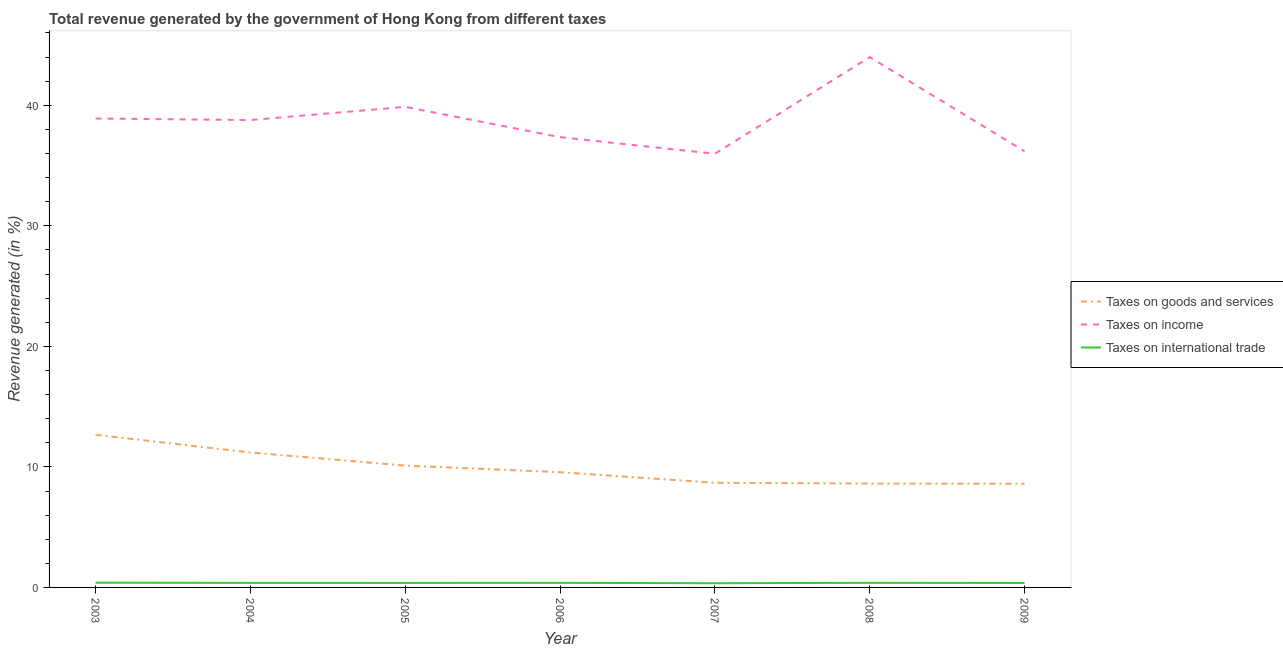How many different coloured lines are there?
Offer a terse response. 3. Does the line corresponding to percentage of revenue generated by tax on international trade intersect with the line corresponding to percentage of revenue generated by taxes on goods and services?
Your answer should be very brief. No. Is the number of lines equal to the number of legend labels?
Your answer should be very brief. Yes. What is the percentage of revenue generated by taxes on goods and services in 2003?
Provide a succinct answer. 12.66. Across all years, what is the maximum percentage of revenue generated by taxes on goods and services?
Provide a short and direct response. 12.66. Across all years, what is the minimum percentage of revenue generated by tax on international trade?
Your answer should be compact. 0.35. What is the total percentage of revenue generated by tax on international trade in the graph?
Keep it short and to the point. 2.62. What is the difference between the percentage of revenue generated by tax on international trade in 2003 and that in 2009?
Keep it short and to the point. 0.03. What is the difference between the percentage of revenue generated by taxes on goods and services in 2006 and the percentage of revenue generated by tax on international trade in 2005?
Offer a terse response. 9.18. What is the average percentage of revenue generated by taxes on income per year?
Your answer should be very brief. 38.72. In the year 2005, what is the difference between the percentage of revenue generated by taxes on income and percentage of revenue generated by taxes on goods and services?
Give a very brief answer. 29.76. What is the ratio of the percentage of revenue generated by taxes on income in 2003 to that in 2006?
Offer a very short reply. 1.04. Is the percentage of revenue generated by taxes on goods and services in 2008 less than that in 2009?
Provide a succinct answer. No. What is the difference between the highest and the second highest percentage of revenue generated by taxes on goods and services?
Your response must be concise. 1.47. What is the difference between the highest and the lowest percentage of revenue generated by taxes on goods and services?
Make the answer very short. 4.06. Is the sum of the percentage of revenue generated by taxes on goods and services in 2003 and 2004 greater than the maximum percentage of revenue generated by tax on international trade across all years?
Your answer should be compact. Yes. Is it the case that in every year, the sum of the percentage of revenue generated by taxes on goods and services and percentage of revenue generated by taxes on income is greater than the percentage of revenue generated by tax on international trade?
Your response must be concise. Yes. Does the percentage of revenue generated by taxes on income monotonically increase over the years?
Make the answer very short. No. How many lines are there?
Offer a very short reply. 3. Where does the legend appear in the graph?
Provide a succinct answer. Center right. How many legend labels are there?
Keep it short and to the point. 3. What is the title of the graph?
Give a very brief answer. Total revenue generated by the government of Hong Kong from different taxes. What is the label or title of the X-axis?
Your answer should be compact. Year. What is the label or title of the Y-axis?
Your answer should be very brief. Revenue generated (in %). What is the Revenue generated (in %) in Taxes on goods and services in 2003?
Keep it short and to the point. 12.66. What is the Revenue generated (in %) in Taxes on income in 2003?
Give a very brief answer. 38.9. What is the Revenue generated (in %) of Taxes on international trade in 2003?
Provide a short and direct response. 0.39. What is the Revenue generated (in %) in Taxes on goods and services in 2004?
Offer a very short reply. 11.2. What is the Revenue generated (in %) in Taxes on income in 2004?
Your answer should be very brief. 38.77. What is the Revenue generated (in %) in Taxes on international trade in 2004?
Provide a short and direct response. 0.38. What is the Revenue generated (in %) of Taxes on goods and services in 2005?
Offer a terse response. 10.11. What is the Revenue generated (in %) in Taxes on income in 2005?
Give a very brief answer. 39.87. What is the Revenue generated (in %) of Taxes on international trade in 2005?
Provide a succinct answer. 0.38. What is the Revenue generated (in %) in Taxes on goods and services in 2006?
Offer a terse response. 9.56. What is the Revenue generated (in %) in Taxes on income in 2006?
Provide a short and direct response. 37.36. What is the Revenue generated (in %) in Taxes on international trade in 2006?
Offer a very short reply. 0.38. What is the Revenue generated (in %) of Taxes on goods and services in 2007?
Provide a short and direct response. 8.68. What is the Revenue generated (in %) of Taxes on income in 2007?
Keep it short and to the point. 35.98. What is the Revenue generated (in %) in Taxes on international trade in 2007?
Your answer should be very brief. 0.35. What is the Revenue generated (in %) in Taxes on goods and services in 2008?
Offer a very short reply. 8.62. What is the Revenue generated (in %) of Taxes on income in 2008?
Your answer should be compact. 44. What is the Revenue generated (in %) of Taxes on international trade in 2008?
Keep it short and to the point. 0.38. What is the Revenue generated (in %) in Taxes on goods and services in 2009?
Offer a terse response. 8.6. What is the Revenue generated (in %) of Taxes on income in 2009?
Your answer should be compact. 36.18. What is the Revenue generated (in %) in Taxes on international trade in 2009?
Give a very brief answer. 0.37. Across all years, what is the maximum Revenue generated (in %) of Taxes on goods and services?
Offer a terse response. 12.66. Across all years, what is the maximum Revenue generated (in %) of Taxes on income?
Make the answer very short. 44. Across all years, what is the maximum Revenue generated (in %) in Taxes on international trade?
Provide a short and direct response. 0.39. Across all years, what is the minimum Revenue generated (in %) of Taxes on goods and services?
Ensure brevity in your answer.  8.6. Across all years, what is the minimum Revenue generated (in %) of Taxes on income?
Give a very brief answer. 35.98. Across all years, what is the minimum Revenue generated (in %) of Taxes on international trade?
Your answer should be compact. 0.35. What is the total Revenue generated (in %) of Taxes on goods and services in the graph?
Make the answer very short. 69.43. What is the total Revenue generated (in %) in Taxes on income in the graph?
Your answer should be compact. 271.06. What is the total Revenue generated (in %) in Taxes on international trade in the graph?
Keep it short and to the point. 2.62. What is the difference between the Revenue generated (in %) of Taxes on goods and services in 2003 and that in 2004?
Keep it short and to the point. 1.47. What is the difference between the Revenue generated (in %) in Taxes on income in 2003 and that in 2004?
Your answer should be compact. 0.13. What is the difference between the Revenue generated (in %) in Taxes on international trade in 2003 and that in 2004?
Make the answer very short. 0.02. What is the difference between the Revenue generated (in %) of Taxes on goods and services in 2003 and that in 2005?
Your response must be concise. 2.56. What is the difference between the Revenue generated (in %) of Taxes on income in 2003 and that in 2005?
Give a very brief answer. -0.97. What is the difference between the Revenue generated (in %) in Taxes on international trade in 2003 and that in 2005?
Keep it short and to the point. 0.02. What is the difference between the Revenue generated (in %) in Taxes on goods and services in 2003 and that in 2006?
Provide a short and direct response. 3.1. What is the difference between the Revenue generated (in %) of Taxes on income in 2003 and that in 2006?
Give a very brief answer. 1.55. What is the difference between the Revenue generated (in %) of Taxes on international trade in 2003 and that in 2006?
Give a very brief answer. 0.01. What is the difference between the Revenue generated (in %) of Taxes on goods and services in 2003 and that in 2007?
Your answer should be very brief. 3.98. What is the difference between the Revenue generated (in %) in Taxes on income in 2003 and that in 2007?
Keep it short and to the point. 2.93. What is the difference between the Revenue generated (in %) in Taxes on international trade in 2003 and that in 2007?
Your answer should be compact. 0.05. What is the difference between the Revenue generated (in %) in Taxes on goods and services in 2003 and that in 2008?
Your response must be concise. 4.05. What is the difference between the Revenue generated (in %) in Taxes on income in 2003 and that in 2008?
Keep it short and to the point. -5.09. What is the difference between the Revenue generated (in %) in Taxes on international trade in 2003 and that in 2008?
Provide a succinct answer. 0.01. What is the difference between the Revenue generated (in %) of Taxes on goods and services in 2003 and that in 2009?
Your answer should be very brief. 4.06. What is the difference between the Revenue generated (in %) of Taxes on income in 2003 and that in 2009?
Keep it short and to the point. 2.72. What is the difference between the Revenue generated (in %) in Taxes on international trade in 2003 and that in 2009?
Keep it short and to the point. 0.03. What is the difference between the Revenue generated (in %) in Taxes on goods and services in 2004 and that in 2005?
Ensure brevity in your answer.  1.09. What is the difference between the Revenue generated (in %) of Taxes on income in 2004 and that in 2005?
Your response must be concise. -1.1. What is the difference between the Revenue generated (in %) in Taxes on international trade in 2004 and that in 2005?
Your answer should be very brief. 0. What is the difference between the Revenue generated (in %) of Taxes on goods and services in 2004 and that in 2006?
Give a very brief answer. 1.64. What is the difference between the Revenue generated (in %) in Taxes on income in 2004 and that in 2006?
Give a very brief answer. 1.42. What is the difference between the Revenue generated (in %) of Taxes on international trade in 2004 and that in 2006?
Your response must be concise. -0. What is the difference between the Revenue generated (in %) of Taxes on goods and services in 2004 and that in 2007?
Your answer should be very brief. 2.51. What is the difference between the Revenue generated (in %) in Taxes on income in 2004 and that in 2007?
Your response must be concise. 2.8. What is the difference between the Revenue generated (in %) of Taxes on international trade in 2004 and that in 2007?
Provide a short and direct response. 0.03. What is the difference between the Revenue generated (in %) in Taxes on goods and services in 2004 and that in 2008?
Keep it short and to the point. 2.58. What is the difference between the Revenue generated (in %) of Taxes on income in 2004 and that in 2008?
Your answer should be compact. -5.22. What is the difference between the Revenue generated (in %) of Taxes on international trade in 2004 and that in 2008?
Make the answer very short. -0.01. What is the difference between the Revenue generated (in %) of Taxes on goods and services in 2004 and that in 2009?
Provide a succinct answer. 2.6. What is the difference between the Revenue generated (in %) of Taxes on income in 2004 and that in 2009?
Ensure brevity in your answer.  2.59. What is the difference between the Revenue generated (in %) of Taxes on international trade in 2004 and that in 2009?
Your answer should be very brief. 0.01. What is the difference between the Revenue generated (in %) in Taxes on goods and services in 2005 and that in 2006?
Offer a terse response. 0.55. What is the difference between the Revenue generated (in %) in Taxes on income in 2005 and that in 2006?
Provide a succinct answer. 2.52. What is the difference between the Revenue generated (in %) of Taxes on international trade in 2005 and that in 2006?
Give a very brief answer. -0. What is the difference between the Revenue generated (in %) in Taxes on goods and services in 2005 and that in 2007?
Provide a succinct answer. 1.42. What is the difference between the Revenue generated (in %) in Taxes on income in 2005 and that in 2007?
Offer a very short reply. 3.89. What is the difference between the Revenue generated (in %) of Taxes on international trade in 2005 and that in 2007?
Give a very brief answer. 0.03. What is the difference between the Revenue generated (in %) in Taxes on goods and services in 2005 and that in 2008?
Provide a succinct answer. 1.49. What is the difference between the Revenue generated (in %) of Taxes on income in 2005 and that in 2008?
Keep it short and to the point. -4.13. What is the difference between the Revenue generated (in %) in Taxes on international trade in 2005 and that in 2008?
Provide a succinct answer. -0.01. What is the difference between the Revenue generated (in %) of Taxes on goods and services in 2005 and that in 2009?
Keep it short and to the point. 1.51. What is the difference between the Revenue generated (in %) of Taxes on income in 2005 and that in 2009?
Make the answer very short. 3.69. What is the difference between the Revenue generated (in %) of Taxes on international trade in 2005 and that in 2009?
Ensure brevity in your answer.  0.01. What is the difference between the Revenue generated (in %) of Taxes on goods and services in 2006 and that in 2007?
Keep it short and to the point. 0.88. What is the difference between the Revenue generated (in %) in Taxes on income in 2006 and that in 2007?
Ensure brevity in your answer.  1.38. What is the difference between the Revenue generated (in %) of Taxes on international trade in 2006 and that in 2007?
Offer a terse response. 0.03. What is the difference between the Revenue generated (in %) of Taxes on goods and services in 2006 and that in 2008?
Your response must be concise. 0.94. What is the difference between the Revenue generated (in %) in Taxes on income in 2006 and that in 2008?
Your answer should be compact. -6.64. What is the difference between the Revenue generated (in %) in Taxes on international trade in 2006 and that in 2008?
Your answer should be very brief. -0. What is the difference between the Revenue generated (in %) in Taxes on goods and services in 2006 and that in 2009?
Give a very brief answer. 0.96. What is the difference between the Revenue generated (in %) of Taxes on income in 2006 and that in 2009?
Ensure brevity in your answer.  1.17. What is the difference between the Revenue generated (in %) in Taxes on international trade in 2006 and that in 2009?
Offer a terse response. 0.01. What is the difference between the Revenue generated (in %) of Taxes on goods and services in 2007 and that in 2008?
Provide a succinct answer. 0.07. What is the difference between the Revenue generated (in %) in Taxes on income in 2007 and that in 2008?
Your answer should be very brief. -8.02. What is the difference between the Revenue generated (in %) of Taxes on international trade in 2007 and that in 2008?
Give a very brief answer. -0.04. What is the difference between the Revenue generated (in %) in Taxes on goods and services in 2007 and that in 2009?
Keep it short and to the point. 0.08. What is the difference between the Revenue generated (in %) of Taxes on income in 2007 and that in 2009?
Offer a very short reply. -0.21. What is the difference between the Revenue generated (in %) of Taxes on international trade in 2007 and that in 2009?
Your response must be concise. -0.02. What is the difference between the Revenue generated (in %) of Taxes on goods and services in 2008 and that in 2009?
Offer a terse response. 0.02. What is the difference between the Revenue generated (in %) in Taxes on income in 2008 and that in 2009?
Your response must be concise. 7.81. What is the difference between the Revenue generated (in %) of Taxes on international trade in 2008 and that in 2009?
Your response must be concise. 0.01. What is the difference between the Revenue generated (in %) of Taxes on goods and services in 2003 and the Revenue generated (in %) of Taxes on income in 2004?
Ensure brevity in your answer.  -26.11. What is the difference between the Revenue generated (in %) of Taxes on goods and services in 2003 and the Revenue generated (in %) of Taxes on international trade in 2004?
Your answer should be compact. 12.29. What is the difference between the Revenue generated (in %) in Taxes on income in 2003 and the Revenue generated (in %) in Taxes on international trade in 2004?
Your response must be concise. 38.53. What is the difference between the Revenue generated (in %) in Taxes on goods and services in 2003 and the Revenue generated (in %) in Taxes on income in 2005?
Provide a succinct answer. -27.21. What is the difference between the Revenue generated (in %) in Taxes on goods and services in 2003 and the Revenue generated (in %) in Taxes on international trade in 2005?
Give a very brief answer. 12.29. What is the difference between the Revenue generated (in %) of Taxes on income in 2003 and the Revenue generated (in %) of Taxes on international trade in 2005?
Offer a very short reply. 38.53. What is the difference between the Revenue generated (in %) in Taxes on goods and services in 2003 and the Revenue generated (in %) in Taxes on income in 2006?
Offer a very short reply. -24.69. What is the difference between the Revenue generated (in %) in Taxes on goods and services in 2003 and the Revenue generated (in %) in Taxes on international trade in 2006?
Keep it short and to the point. 12.28. What is the difference between the Revenue generated (in %) in Taxes on income in 2003 and the Revenue generated (in %) in Taxes on international trade in 2006?
Offer a very short reply. 38.52. What is the difference between the Revenue generated (in %) in Taxes on goods and services in 2003 and the Revenue generated (in %) in Taxes on income in 2007?
Offer a very short reply. -23.31. What is the difference between the Revenue generated (in %) in Taxes on goods and services in 2003 and the Revenue generated (in %) in Taxes on international trade in 2007?
Keep it short and to the point. 12.32. What is the difference between the Revenue generated (in %) in Taxes on income in 2003 and the Revenue generated (in %) in Taxes on international trade in 2007?
Ensure brevity in your answer.  38.56. What is the difference between the Revenue generated (in %) in Taxes on goods and services in 2003 and the Revenue generated (in %) in Taxes on income in 2008?
Your answer should be very brief. -31.33. What is the difference between the Revenue generated (in %) of Taxes on goods and services in 2003 and the Revenue generated (in %) of Taxes on international trade in 2008?
Offer a terse response. 12.28. What is the difference between the Revenue generated (in %) of Taxes on income in 2003 and the Revenue generated (in %) of Taxes on international trade in 2008?
Your answer should be compact. 38.52. What is the difference between the Revenue generated (in %) in Taxes on goods and services in 2003 and the Revenue generated (in %) in Taxes on income in 2009?
Make the answer very short. -23.52. What is the difference between the Revenue generated (in %) in Taxes on goods and services in 2003 and the Revenue generated (in %) in Taxes on international trade in 2009?
Keep it short and to the point. 12.3. What is the difference between the Revenue generated (in %) of Taxes on income in 2003 and the Revenue generated (in %) of Taxes on international trade in 2009?
Offer a very short reply. 38.54. What is the difference between the Revenue generated (in %) of Taxes on goods and services in 2004 and the Revenue generated (in %) of Taxes on income in 2005?
Offer a very short reply. -28.67. What is the difference between the Revenue generated (in %) of Taxes on goods and services in 2004 and the Revenue generated (in %) of Taxes on international trade in 2005?
Ensure brevity in your answer.  10.82. What is the difference between the Revenue generated (in %) in Taxes on income in 2004 and the Revenue generated (in %) in Taxes on international trade in 2005?
Offer a very short reply. 38.4. What is the difference between the Revenue generated (in %) in Taxes on goods and services in 2004 and the Revenue generated (in %) in Taxes on income in 2006?
Keep it short and to the point. -26.16. What is the difference between the Revenue generated (in %) of Taxes on goods and services in 2004 and the Revenue generated (in %) of Taxes on international trade in 2006?
Provide a succinct answer. 10.82. What is the difference between the Revenue generated (in %) in Taxes on income in 2004 and the Revenue generated (in %) in Taxes on international trade in 2006?
Your answer should be compact. 38.39. What is the difference between the Revenue generated (in %) in Taxes on goods and services in 2004 and the Revenue generated (in %) in Taxes on income in 2007?
Keep it short and to the point. -24.78. What is the difference between the Revenue generated (in %) of Taxes on goods and services in 2004 and the Revenue generated (in %) of Taxes on international trade in 2007?
Your answer should be compact. 10.85. What is the difference between the Revenue generated (in %) of Taxes on income in 2004 and the Revenue generated (in %) of Taxes on international trade in 2007?
Ensure brevity in your answer.  38.43. What is the difference between the Revenue generated (in %) of Taxes on goods and services in 2004 and the Revenue generated (in %) of Taxes on income in 2008?
Give a very brief answer. -32.8. What is the difference between the Revenue generated (in %) in Taxes on goods and services in 2004 and the Revenue generated (in %) in Taxes on international trade in 2008?
Give a very brief answer. 10.81. What is the difference between the Revenue generated (in %) of Taxes on income in 2004 and the Revenue generated (in %) of Taxes on international trade in 2008?
Your answer should be compact. 38.39. What is the difference between the Revenue generated (in %) in Taxes on goods and services in 2004 and the Revenue generated (in %) in Taxes on income in 2009?
Offer a terse response. -24.99. What is the difference between the Revenue generated (in %) of Taxes on goods and services in 2004 and the Revenue generated (in %) of Taxes on international trade in 2009?
Your response must be concise. 10.83. What is the difference between the Revenue generated (in %) in Taxes on income in 2004 and the Revenue generated (in %) in Taxes on international trade in 2009?
Provide a succinct answer. 38.41. What is the difference between the Revenue generated (in %) of Taxes on goods and services in 2005 and the Revenue generated (in %) of Taxes on income in 2006?
Offer a very short reply. -27.25. What is the difference between the Revenue generated (in %) of Taxes on goods and services in 2005 and the Revenue generated (in %) of Taxes on international trade in 2006?
Keep it short and to the point. 9.73. What is the difference between the Revenue generated (in %) of Taxes on income in 2005 and the Revenue generated (in %) of Taxes on international trade in 2006?
Make the answer very short. 39.49. What is the difference between the Revenue generated (in %) of Taxes on goods and services in 2005 and the Revenue generated (in %) of Taxes on income in 2007?
Provide a short and direct response. -25.87. What is the difference between the Revenue generated (in %) in Taxes on goods and services in 2005 and the Revenue generated (in %) in Taxes on international trade in 2007?
Ensure brevity in your answer.  9.76. What is the difference between the Revenue generated (in %) of Taxes on income in 2005 and the Revenue generated (in %) of Taxes on international trade in 2007?
Make the answer very short. 39.52. What is the difference between the Revenue generated (in %) of Taxes on goods and services in 2005 and the Revenue generated (in %) of Taxes on income in 2008?
Provide a succinct answer. -33.89. What is the difference between the Revenue generated (in %) of Taxes on goods and services in 2005 and the Revenue generated (in %) of Taxes on international trade in 2008?
Provide a short and direct response. 9.72. What is the difference between the Revenue generated (in %) of Taxes on income in 2005 and the Revenue generated (in %) of Taxes on international trade in 2008?
Your answer should be very brief. 39.49. What is the difference between the Revenue generated (in %) of Taxes on goods and services in 2005 and the Revenue generated (in %) of Taxes on income in 2009?
Offer a very short reply. -26.08. What is the difference between the Revenue generated (in %) in Taxes on goods and services in 2005 and the Revenue generated (in %) in Taxes on international trade in 2009?
Keep it short and to the point. 9.74. What is the difference between the Revenue generated (in %) of Taxes on income in 2005 and the Revenue generated (in %) of Taxes on international trade in 2009?
Ensure brevity in your answer.  39.5. What is the difference between the Revenue generated (in %) of Taxes on goods and services in 2006 and the Revenue generated (in %) of Taxes on income in 2007?
Offer a very short reply. -26.42. What is the difference between the Revenue generated (in %) in Taxes on goods and services in 2006 and the Revenue generated (in %) in Taxes on international trade in 2007?
Provide a succinct answer. 9.21. What is the difference between the Revenue generated (in %) in Taxes on income in 2006 and the Revenue generated (in %) in Taxes on international trade in 2007?
Keep it short and to the point. 37.01. What is the difference between the Revenue generated (in %) of Taxes on goods and services in 2006 and the Revenue generated (in %) of Taxes on income in 2008?
Provide a succinct answer. -34.44. What is the difference between the Revenue generated (in %) in Taxes on goods and services in 2006 and the Revenue generated (in %) in Taxes on international trade in 2008?
Provide a succinct answer. 9.18. What is the difference between the Revenue generated (in %) in Taxes on income in 2006 and the Revenue generated (in %) in Taxes on international trade in 2008?
Give a very brief answer. 36.97. What is the difference between the Revenue generated (in %) of Taxes on goods and services in 2006 and the Revenue generated (in %) of Taxes on income in 2009?
Offer a very short reply. -26.62. What is the difference between the Revenue generated (in %) in Taxes on goods and services in 2006 and the Revenue generated (in %) in Taxes on international trade in 2009?
Keep it short and to the point. 9.19. What is the difference between the Revenue generated (in %) of Taxes on income in 2006 and the Revenue generated (in %) of Taxes on international trade in 2009?
Keep it short and to the point. 36.99. What is the difference between the Revenue generated (in %) in Taxes on goods and services in 2007 and the Revenue generated (in %) in Taxes on income in 2008?
Keep it short and to the point. -35.31. What is the difference between the Revenue generated (in %) in Taxes on goods and services in 2007 and the Revenue generated (in %) in Taxes on international trade in 2008?
Provide a short and direct response. 8.3. What is the difference between the Revenue generated (in %) of Taxes on income in 2007 and the Revenue generated (in %) of Taxes on international trade in 2008?
Make the answer very short. 35.6. What is the difference between the Revenue generated (in %) of Taxes on goods and services in 2007 and the Revenue generated (in %) of Taxes on income in 2009?
Your response must be concise. -27.5. What is the difference between the Revenue generated (in %) in Taxes on goods and services in 2007 and the Revenue generated (in %) in Taxes on international trade in 2009?
Keep it short and to the point. 8.31. What is the difference between the Revenue generated (in %) of Taxes on income in 2007 and the Revenue generated (in %) of Taxes on international trade in 2009?
Offer a terse response. 35.61. What is the difference between the Revenue generated (in %) in Taxes on goods and services in 2008 and the Revenue generated (in %) in Taxes on income in 2009?
Ensure brevity in your answer.  -27.57. What is the difference between the Revenue generated (in %) of Taxes on goods and services in 2008 and the Revenue generated (in %) of Taxes on international trade in 2009?
Make the answer very short. 8.25. What is the difference between the Revenue generated (in %) in Taxes on income in 2008 and the Revenue generated (in %) in Taxes on international trade in 2009?
Your answer should be compact. 43.63. What is the average Revenue generated (in %) in Taxes on goods and services per year?
Your answer should be very brief. 9.92. What is the average Revenue generated (in %) in Taxes on income per year?
Give a very brief answer. 38.72. What is the average Revenue generated (in %) of Taxes on international trade per year?
Ensure brevity in your answer.  0.38. In the year 2003, what is the difference between the Revenue generated (in %) of Taxes on goods and services and Revenue generated (in %) of Taxes on income?
Offer a very short reply. -26.24. In the year 2003, what is the difference between the Revenue generated (in %) of Taxes on goods and services and Revenue generated (in %) of Taxes on international trade?
Your response must be concise. 12.27. In the year 2003, what is the difference between the Revenue generated (in %) in Taxes on income and Revenue generated (in %) in Taxes on international trade?
Offer a terse response. 38.51. In the year 2004, what is the difference between the Revenue generated (in %) of Taxes on goods and services and Revenue generated (in %) of Taxes on income?
Your answer should be very brief. -27.58. In the year 2004, what is the difference between the Revenue generated (in %) of Taxes on goods and services and Revenue generated (in %) of Taxes on international trade?
Your answer should be very brief. 10.82. In the year 2004, what is the difference between the Revenue generated (in %) in Taxes on income and Revenue generated (in %) in Taxes on international trade?
Give a very brief answer. 38.4. In the year 2005, what is the difference between the Revenue generated (in %) in Taxes on goods and services and Revenue generated (in %) in Taxes on income?
Make the answer very short. -29.76. In the year 2005, what is the difference between the Revenue generated (in %) of Taxes on goods and services and Revenue generated (in %) of Taxes on international trade?
Give a very brief answer. 9.73. In the year 2005, what is the difference between the Revenue generated (in %) in Taxes on income and Revenue generated (in %) in Taxes on international trade?
Keep it short and to the point. 39.5. In the year 2006, what is the difference between the Revenue generated (in %) in Taxes on goods and services and Revenue generated (in %) in Taxes on income?
Your response must be concise. -27.8. In the year 2006, what is the difference between the Revenue generated (in %) of Taxes on goods and services and Revenue generated (in %) of Taxes on international trade?
Your answer should be compact. 9.18. In the year 2006, what is the difference between the Revenue generated (in %) in Taxes on income and Revenue generated (in %) in Taxes on international trade?
Provide a short and direct response. 36.98. In the year 2007, what is the difference between the Revenue generated (in %) of Taxes on goods and services and Revenue generated (in %) of Taxes on income?
Offer a very short reply. -27.3. In the year 2007, what is the difference between the Revenue generated (in %) of Taxes on goods and services and Revenue generated (in %) of Taxes on international trade?
Give a very brief answer. 8.34. In the year 2007, what is the difference between the Revenue generated (in %) in Taxes on income and Revenue generated (in %) in Taxes on international trade?
Offer a very short reply. 35.63. In the year 2008, what is the difference between the Revenue generated (in %) of Taxes on goods and services and Revenue generated (in %) of Taxes on income?
Give a very brief answer. -35.38. In the year 2008, what is the difference between the Revenue generated (in %) in Taxes on goods and services and Revenue generated (in %) in Taxes on international trade?
Give a very brief answer. 8.23. In the year 2008, what is the difference between the Revenue generated (in %) of Taxes on income and Revenue generated (in %) of Taxes on international trade?
Provide a short and direct response. 43.61. In the year 2009, what is the difference between the Revenue generated (in %) of Taxes on goods and services and Revenue generated (in %) of Taxes on income?
Your answer should be compact. -27.58. In the year 2009, what is the difference between the Revenue generated (in %) of Taxes on goods and services and Revenue generated (in %) of Taxes on international trade?
Make the answer very short. 8.23. In the year 2009, what is the difference between the Revenue generated (in %) of Taxes on income and Revenue generated (in %) of Taxes on international trade?
Offer a terse response. 35.82. What is the ratio of the Revenue generated (in %) of Taxes on goods and services in 2003 to that in 2004?
Give a very brief answer. 1.13. What is the ratio of the Revenue generated (in %) in Taxes on international trade in 2003 to that in 2004?
Offer a very short reply. 1.04. What is the ratio of the Revenue generated (in %) of Taxes on goods and services in 2003 to that in 2005?
Give a very brief answer. 1.25. What is the ratio of the Revenue generated (in %) of Taxes on income in 2003 to that in 2005?
Give a very brief answer. 0.98. What is the ratio of the Revenue generated (in %) in Taxes on international trade in 2003 to that in 2005?
Ensure brevity in your answer.  1.05. What is the ratio of the Revenue generated (in %) of Taxes on goods and services in 2003 to that in 2006?
Offer a terse response. 1.32. What is the ratio of the Revenue generated (in %) of Taxes on income in 2003 to that in 2006?
Your answer should be very brief. 1.04. What is the ratio of the Revenue generated (in %) of Taxes on international trade in 2003 to that in 2006?
Provide a succinct answer. 1.04. What is the ratio of the Revenue generated (in %) in Taxes on goods and services in 2003 to that in 2007?
Provide a succinct answer. 1.46. What is the ratio of the Revenue generated (in %) in Taxes on income in 2003 to that in 2007?
Your response must be concise. 1.08. What is the ratio of the Revenue generated (in %) in Taxes on international trade in 2003 to that in 2007?
Keep it short and to the point. 1.13. What is the ratio of the Revenue generated (in %) in Taxes on goods and services in 2003 to that in 2008?
Your response must be concise. 1.47. What is the ratio of the Revenue generated (in %) in Taxes on income in 2003 to that in 2008?
Provide a short and direct response. 0.88. What is the ratio of the Revenue generated (in %) in Taxes on international trade in 2003 to that in 2008?
Offer a terse response. 1.03. What is the ratio of the Revenue generated (in %) of Taxes on goods and services in 2003 to that in 2009?
Keep it short and to the point. 1.47. What is the ratio of the Revenue generated (in %) in Taxes on income in 2003 to that in 2009?
Provide a succinct answer. 1.08. What is the ratio of the Revenue generated (in %) in Taxes on international trade in 2003 to that in 2009?
Give a very brief answer. 1.07. What is the ratio of the Revenue generated (in %) in Taxes on goods and services in 2004 to that in 2005?
Your answer should be compact. 1.11. What is the ratio of the Revenue generated (in %) in Taxes on income in 2004 to that in 2005?
Ensure brevity in your answer.  0.97. What is the ratio of the Revenue generated (in %) in Taxes on international trade in 2004 to that in 2005?
Provide a succinct answer. 1. What is the ratio of the Revenue generated (in %) in Taxes on goods and services in 2004 to that in 2006?
Offer a very short reply. 1.17. What is the ratio of the Revenue generated (in %) of Taxes on income in 2004 to that in 2006?
Make the answer very short. 1.04. What is the ratio of the Revenue generated (in %) in Taxes on international trade in 2004 to that in 2006?
Your answer should be very brief. 0.99. What is the ratio of the Revenue generated (in %) in Taxes on goods and services in 2004 to that in 2007?
Provide a short and direct response. 1.29. What is the ratio of the Revenue generated (in %) in Taxes on income in 2004 to that in 2007?
Keep it short and to the point. 1.08. What is the ratio of the Revenue generated (in %) in Taxes on international trade in 2004 to that in 2007?
Keep it short and to the point. 1.09. What is the ratio of the Revenue generated (in %) in Taxes on goods and services in 2004 to that in 2008?
Keep it short and to the point. 1.3. What is the ratio of the Revenue generated (in %) of Taxes on income in 2004 to that in 2008?
Offer a very short reply. 0.88. What is the ratio of the Revenue generated (in %) of Taxes on international trade in 2004 to that in 2008?
Provide a succinct answer. 0.99. What is the ratio of the Revenue generated (in %) of Taxes on goods and services in 2004 to that in 2009?
Your answer should be very brief. 1.3. What is the ratio of the Revenue generated (in %) in Taxes on income in 2004 to that in 2009?
Offer a very short reply. 1.07. What is the ratio of the Revenue generated (in %) in Taxes on international trade in 2004 to that in 2009?
Provide a short and direct response. 1.02. What is the ratio of the Revenue generated (in %) in Taxes on goods and services in 2005 to that in 2006?
Keep it short and to the point. 1.06. What is the ratio of the Revenue generated (in %) in Taxes on income in 2005 to that in 2006?
Offer a very short reply. 1.07. What is the ratio of the Revenue generated (in %) in Taxes on international trade in 2005 to that in 2006?
Offer a very short reply. 0.99. What is the ratio of the Revenue generated (in %) in Taxes on goods and services in 2005 to that in 2007?
Make the answer very short. 1.16. What is the ratio of the Revenue generated (in %) of Taxes on income in 2005 to that in 2007?
Make the answer very short. 1.11. What is the ratio of the Revenue generated (in %) in Taxes on international trade in 2005 to that in 2007?
Your response must be concise. 1.08. What is the ratio of the Revenue generated (in %) of Taxes on goods and services in 2005 to that in 2008?
Your response must be concise. 1.17. What is the ratio of the Revenue generated (in %) of Taxes on income in 2005 to that in 2008?
Provide a short and direct response. 0.91. What is the ratio of the Revenue generated (in %) of Taxes on international trade in 2005 to that in 2008?
Keep it short and to the point. 0.98. What is the ratio of the Revenue generated (in %) in Taxes on goods and services in 2005 to that in 2009?
Provide a succinct answer. 1.18. What is the ratio of the Revenue generated (in %) in Taxes on income in 2005 to that in 2009?
Your answer should be very brief. 1.1. What is the ratio of the Revenue generated (in %) of Taxes on international trade in 2005 to that in 2009?
Give a very brief answer. 1.02. What is the ratio of the Revenue generated (in %) of Taxes on goods and services in 2006 to that in 2007?
Ensure brevity in your answer.  1.1. What is the ratio of the Revenue generated (in %) in Taxes on income in 2006 to that in 2007?
Provide a short and direct response. 1.04. What is the ratio of the Revenue generated (in %) of Taxes on international trade in 2006 to that in 2007?
Offer a very short reply. 1.09. What is the ratio of the Revenue generated (in %) of Taxes on goods and services in 2006 to that in 2008?
Your response must be concise. 1.11. What is the ratio of the Revenue generated (in %) in Taxes on income in 2006 to that in 2008?
Your response must be concise. 0.85. What is the ratio of the Revenue generated (in %) in Taxes on international trade in 2006 to that in 2008?
Make the answer very short. 0.99. What is the ratio of the Revenue generated (in %) of Taxes on goods and services in 2006 to that in 2009?
Provide a succinct answer. 1.11. What is the ratio of the Revenue generated (in %) of Taxes on income in 2006 to that in 2009?
Ensure brevity in your answer.  1.03. What is the ratio of the Revenue generated (in %) in Taxes on international trade in 2006 to that in 2009?
Offer a very short reply. 1.03. What is the ratio of the Revenue generated (in %) of Taxes on goods and services in 2007 to that in 2008?
Offer a very short reply. 1.01. What is the ratio of the Revenue generated (in %) in Taxes on income in 2007 to that in 2008?
Keep it short and to the point. 0.82. What is the ratio of the Revenue generated (in %) of Taxes on international trade in 2007 to that in 2008?
Make the answer very short. 0.91. What is the ratio of the Revenue generated (in %) in Taxes on goods and services in 2007 to that in 2009?
Your answer should be very brief. 1.01. What is the ratio of the Revenue generated (in %) in Taxes on income in 2007 to that in 2009?
Your answer should be compact. 0.99. What is the ratio of the Revenue generated (in %) of Taxes on international trade in 2007 to that in 2009?
Provide a succinct answer. 0.94. What is the ratio of the Revenue generated (in %) in Taxes on goods and services in 2008 to that in 2009?
Offer a very short reply. 1. What is the ratio of the Revenue generated (in %) of Taxes on income in 2008 to that in 2009?
Make the answer very short. 1.22. What is the ratio of the Revenue generated (in %) in Taxes on international trade in 2008 to that in 2009?
Your answer should be very brief. 1.04. What is the difference between the highest and the second highest Revenue generated (in %) in Taxes on goods and services?
Ensure brevity in your answer.  1.47. What is the difference between the highest and the second highest Revenue generated (in %) of Taxes on income?
Your response must be concise. 4.13. What is the difference between the highest and the second highest Revenue generated (in %) in Taxes on international trade?
Your response must be concise. 0.01. What is the difference between the highest and the lowest Revenue generated (in %) of Taxes on goods and services?
Your answer should be compact. 4.06. What is the difference between the highest and the lowest Revenue generated (in %) in Taxes on income?
Ensure brevity in your answer.  8.02. What is the difference between the highest and the lowest Revenue generated (in %) in Taxes on international trade?
Give a very brief answer. 0.05. 